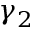Convert formula to latex. <formula><loc_0><loc_0><loc_500><loc_500>\gamma _ { 2 }</formula> 